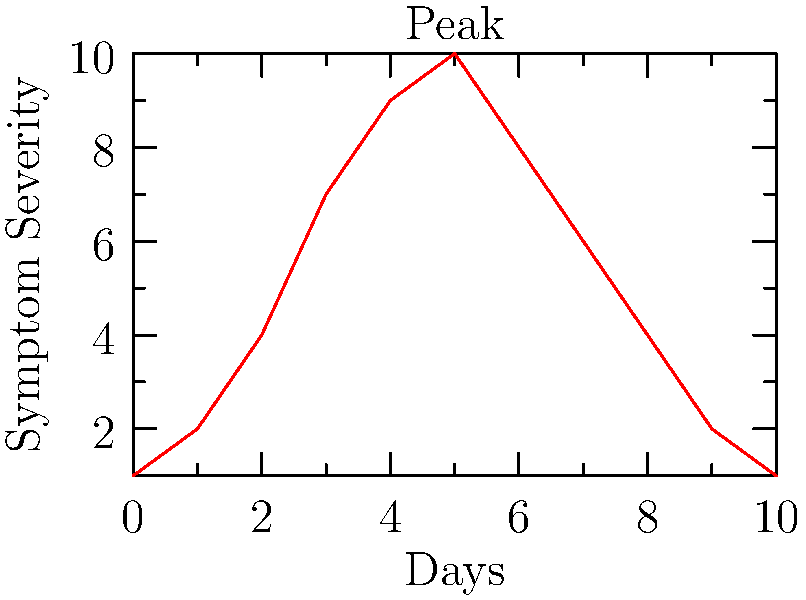Based on the line graph showing symptom severity over time for a rare infectious disease, on which day did the symptoms reach their peak intensity? To determine the day when symptoms reached their peak intensity:

1. Examine the y-axis, which represents symptom severity.
2. Scan the line graph to find the highest point on the curve.
3. The highest point corresponds to the maximum symptom severity.
4. Locate the x-axis value (day) that aligns with this peak.

From the graph, we can observe:
- The line starts at a low severity on day 0.
- It rises sharply over the first few days.
- The curve reaches its highest point on day 5.
- After day 5, the severity begins to decline.

Therefore, the symptoms reached their peak intensity on day 5 of the disease progression.
Answer: Day 5 